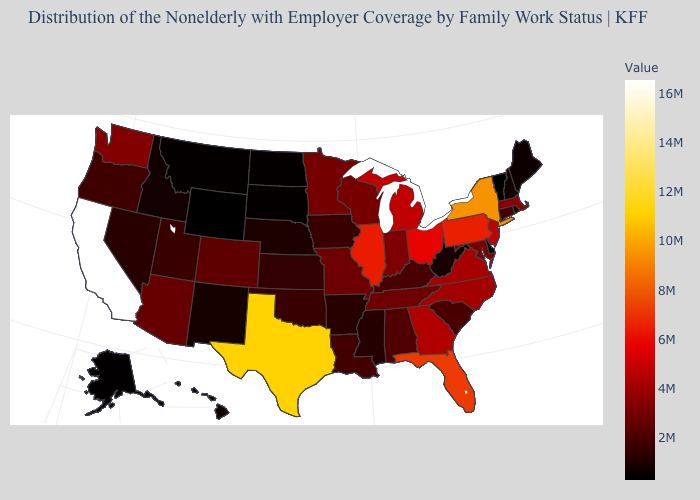Does California have the highest value in the West?
Concise answer only. Yes. Among the states that border Georgia , which have the lowest value?
Answer briefly. South Carolina. Among the states that border Oklahoma , does Texas have the highest value?
Be succinct. Yes. Which states have the lowest value in the West?
Give a very brief answer. Wyoming. Among the states that border Colorado , does Oklahoma have the lowest value?
Quick response, please. No. 